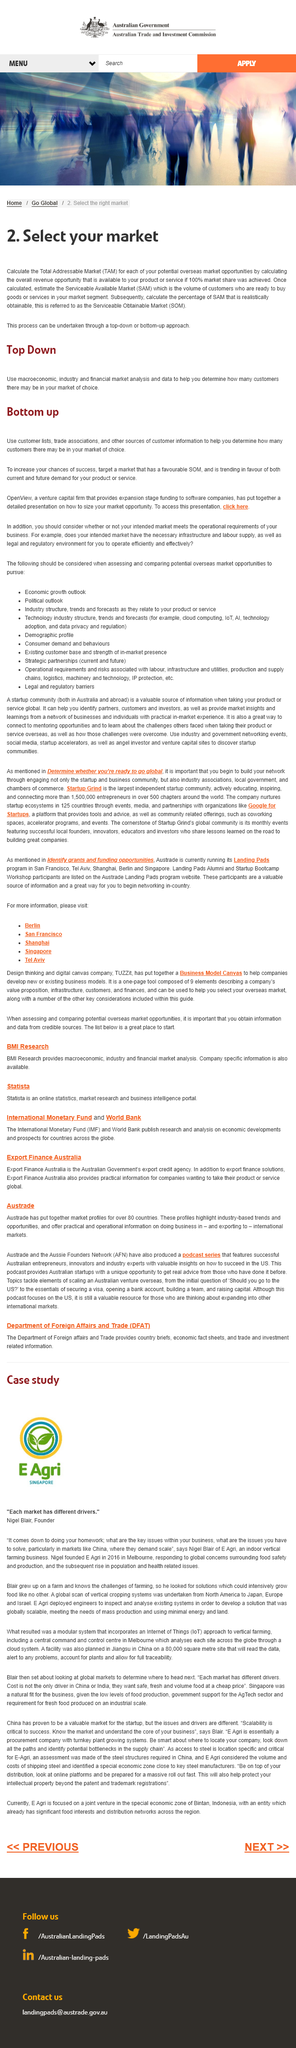Highlight a few significant elements in this photo. It is recommended to use macroeconomic analysis when determining the reach in a market of choice. SOM stands for Serviceable Obtainable Market, representing a market segment that can be realistically targeted with a particular product or service. Total Addressable Market" is a commonly used term in business and refers to the total potential market for a company's goods or services. It is used to describe the overall size of the market that a company can potentially sell its products or services to. In simpler terms, TAM refers to the size of the market that a company can target with its offerings. 